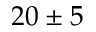<formula> <loc_0><loc_0><loc_500><loc_500>2 0 \pm 5</formula> 